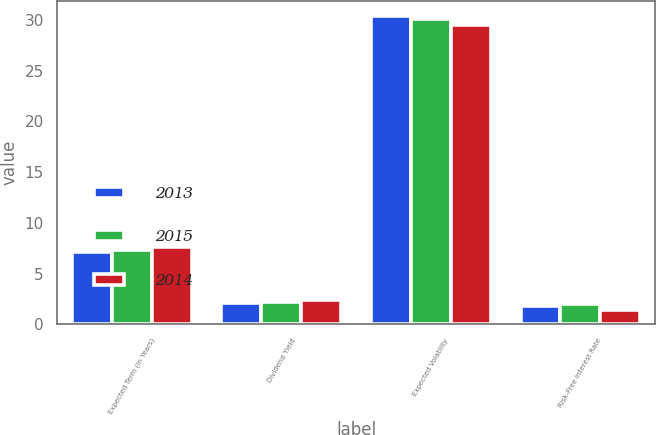Convert chart to OTSL. <chart><loc_0><loc_0><loc_500><loc_500><stacked_bar_chart><ecel><fcel>Expected Term (in Years)<fcel>Dividend Yield<fcel>Expected Volatility<fcel>Risk-Free Interest Rate<nl><fcel>2013<fcel>7.1<fcel>2.07<fcel>30.4<fcel>1.83<nl><fcel>2015<fcel>7.3<fcel>2.16<fcel>30.1<fcel>2.02<nl><fcel>2014<fcel>7.6<fcel>2.38<fcel>29.5<fcel>1.43<nl></chart> 